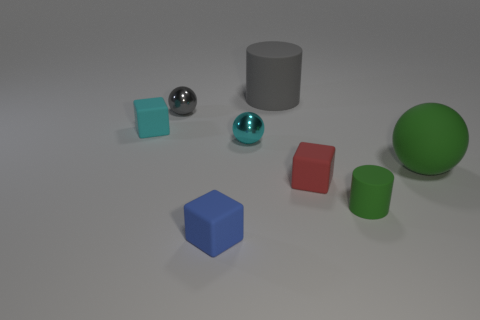Add 2 small matte cylinders. How many objects exist? 10 Subtract all tiny blue matte blocks. How many blocks are left? 2 Subtract all gray cylinders. How many cylinders are left? 1 Subtract 2 cubes. How many cubes are left? 1 Subtract all purple spheres. Subtract all yellow cylinders. How many spheres are left? 3 Subtract all cyan cylinders. How many purple cubes are left? 0 Subtract all small gray rubber cylinders. Subtract all red matte cubes. How many objects are left? 7 Add 8 large things. How many large things are left? 10 Add 2 gray matte cylinders. How many gray matte cylinders exist? 3 Subtract 0 green cubes. How many objects are left? 8 